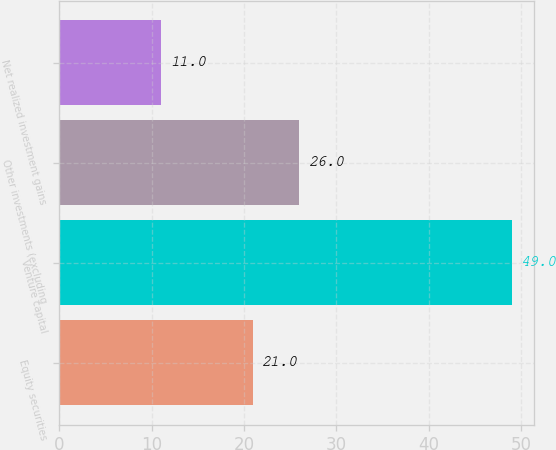<chart> <loc_0><loc_0><loc_500><loc_500><bar_chart><fcel>Equity securities<fcel>Venture capital<fcel>Other investments (excluding<fcel>Net realized investment gains<nl><fcel>21<fcel>49<fcel>26<fcel>11<nl></chart> 